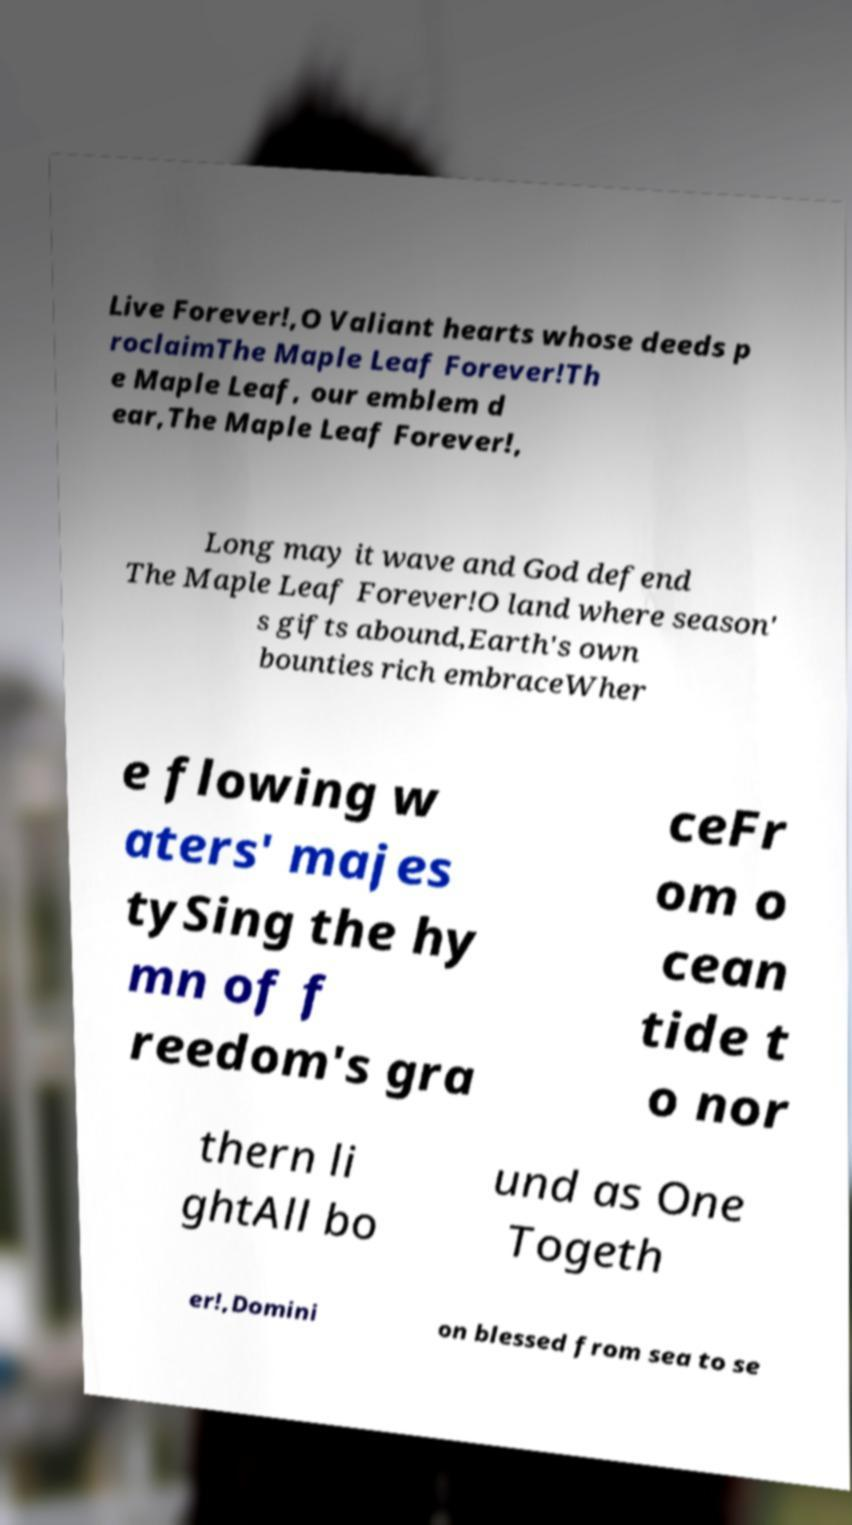What messages or text are displayed in this image? I need them in a readable, typed format. Live Forever!,O Valiant hearts whose deeds p roclaimThe Maple Leaf Forever!Th e Maple Leaf, our emblem d ear,The Maple Leaf Forever!, Long may it wave and God defend The Maple Leaf Forever!O land where season' s gifts abound,Earth's own bounties rich embraceWher e flowing w aters' majes tySing the hy mn of f reedom's gra ceFr om o cean tide t o nor thern li ghtAll bo und as One Togeth er!,Domini on blessed from sea to se 